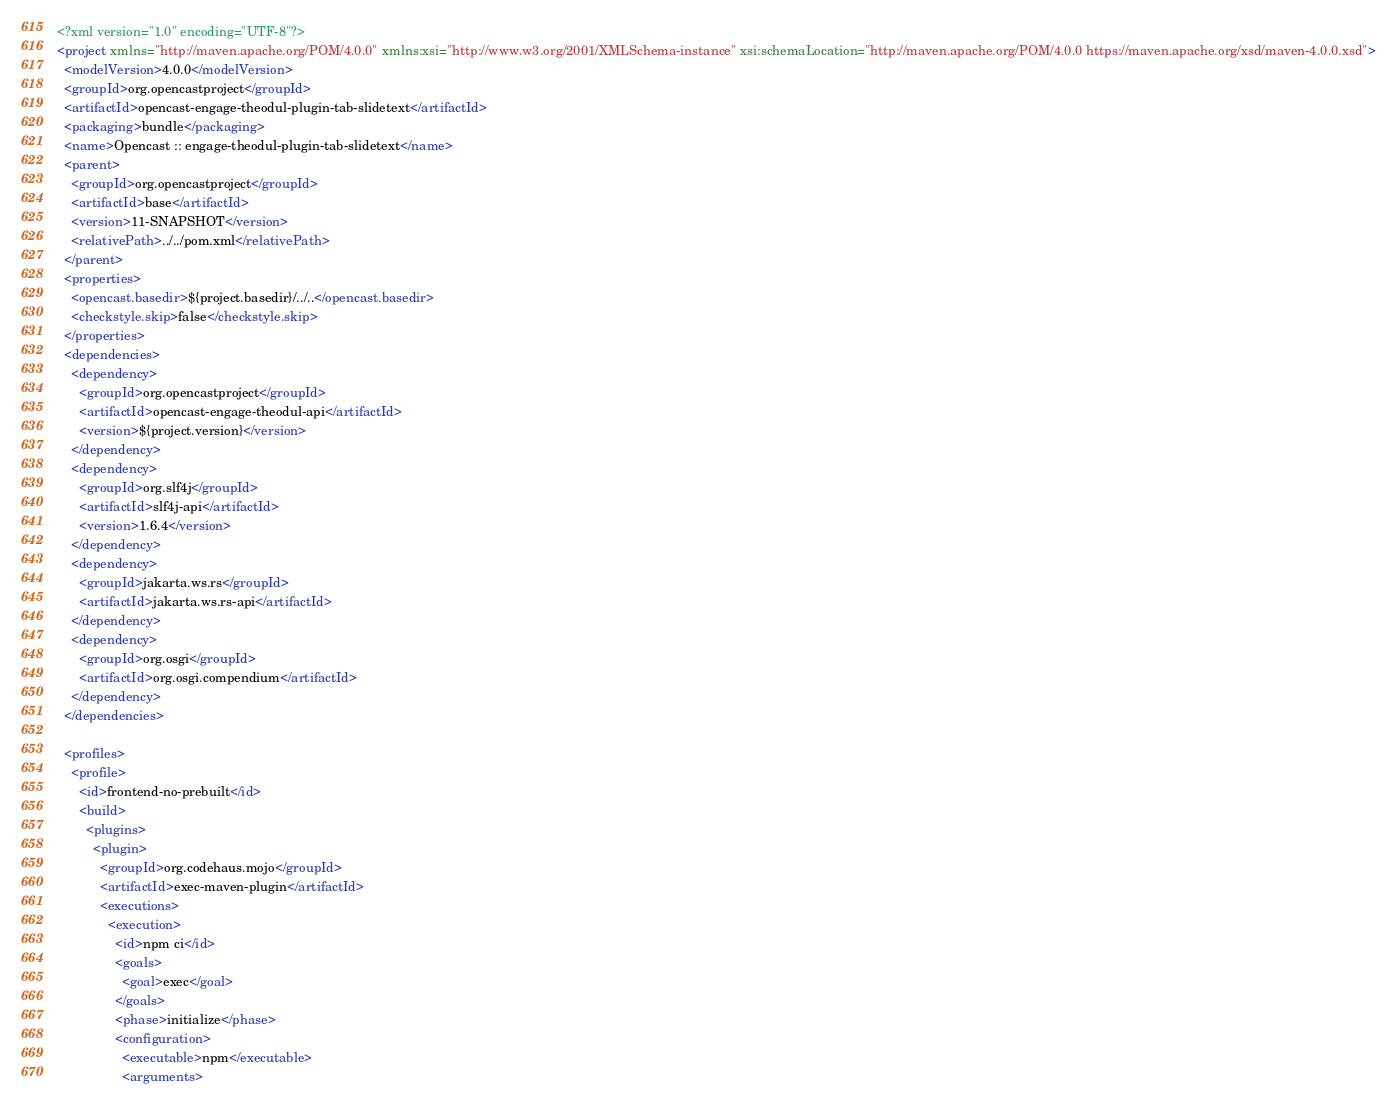<code> <loc_0><loc_0><loc_500><loc_500><_XML_><?xml version="1.0" encoding="UTF-8"?>
<project xmlns="http://maven.apache.org/POM/4.0.0" xmlns:xsi="http://www.w3.org/2001/XMLSchema-instance" xsi:schemaLocation="http://maven.apache.org/POM/4.0.0 https://maven.apache.org/xsd/maven-4.0.0.xsd">
  <modelVersion>4.0.0</modelVersion>
  <groupId>org.opencastproject</groupId>
  <artifactId>opencast-engage-theodul-plugin-tab-slidetext</artifactId>
  <packaging>bundle</packaging>
  <name>Opencast :: engage-theodul-plugin-tab-slidetext</name>
  <parent>
    <groupId>org.opencastproject</groupId>
    <artifactId>base</artifactId>
    <version>11-SNAPSHOT</version>
    <relativePath>../../pom.xml</relativePath>
  </parent>
  <properties>
    <opencast.basedir>${project.basedir}/../..</opencast.basedir>
    <checkstyle.skip>false</checkstyle.skip>
  </properties>
  <dependencies>
    <dependency>
      <groupId>org.opencastproject</groupId>
      <artifactId>opencast-engage-theodul-api</artifactId>
      <version>${project.version}</version>
    </dependency>
    <dependency>
      <groupId>org.slf4j</groupId>
      <artifactId>slf4j-api</artifactId>
      <version>1.6.4</version>
    </dependency>
    <dependency>
      <groupId>jakarta.ws.rs</groupId>
      <artifactId>jakarta.ws.rs-api</artifactId>
    </dependency>
    <dependency>
      <groupId>org.osgi</groupId>
      <artifactId>org.osgi.compendium</artifactId>
    </dependency>
  </dependencies>

  <profiles>
    <profile>
      <id>frontend-no-prebuilt</id>
      <build>
        <plugins>
          <plugin>
            <groupId>org.codehaus.mojo</groupId>
            <artifactId>exec-maven-plugin</artifactId>
            <executions>
              <execution>
                <id>npm ci</id>
                <goals>
                  <goal>exec</goal>
                </goals>
                <phase>initialize</phase>
                <configuration>
                  <executable>npm</executable>
                  <arguments></code> 